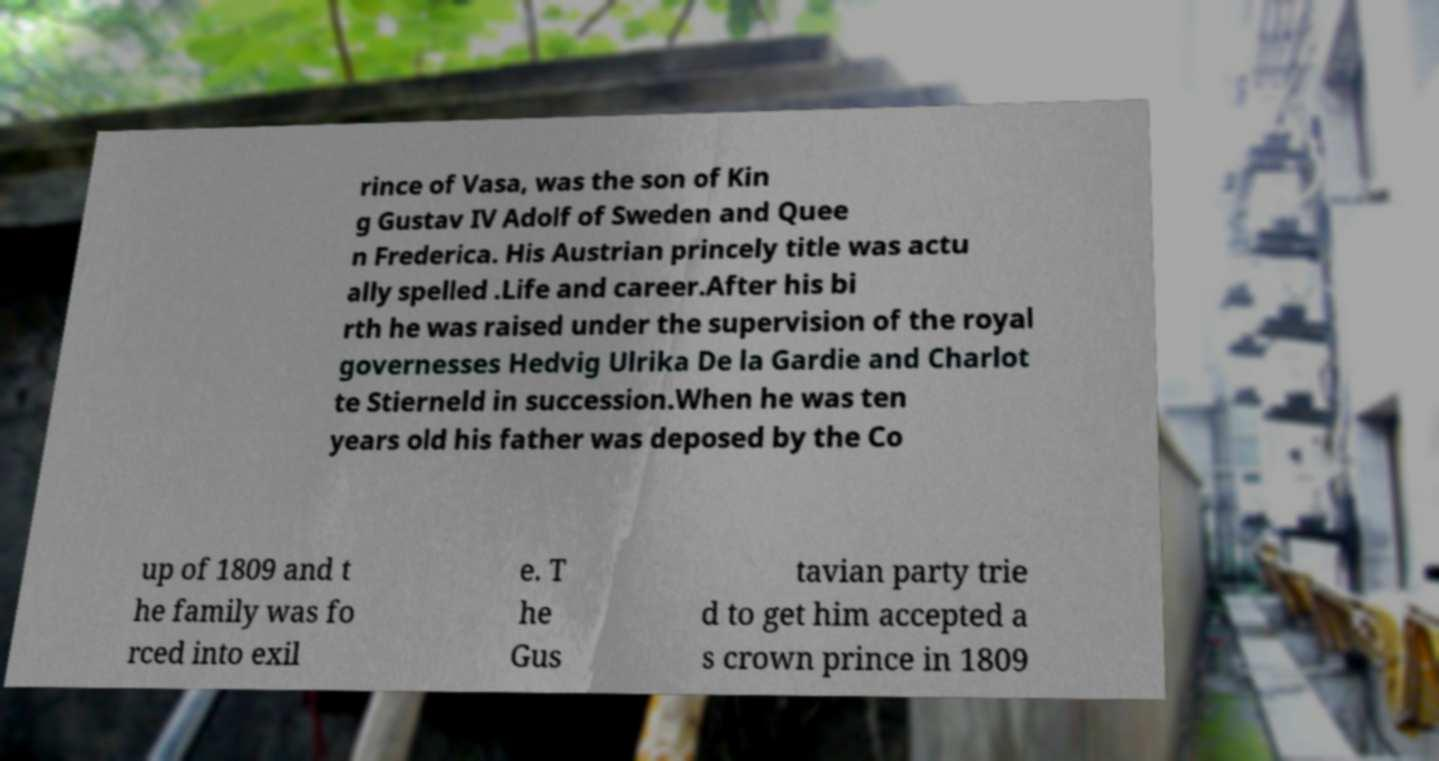There's text embedded in this image that I need extracted. Can you transcribe it verbatim? rince of Vasa, was the son of Kin g Gustav IV Adolf of Sweden and Quee n Frederica. His Austrian princely title was actu ally spelled .Life and career.After his bi rth he was raised under the supervision of the royal governesses Hedvig Ulrika De la Gardie and Charlot te Stierneld in succession.When he was ten years old his father was deposed by the Co up of 1809 and t he family was fo rced into exil e. T he Gus tavian party trie d to get him accepted a s crown prince in 1809 